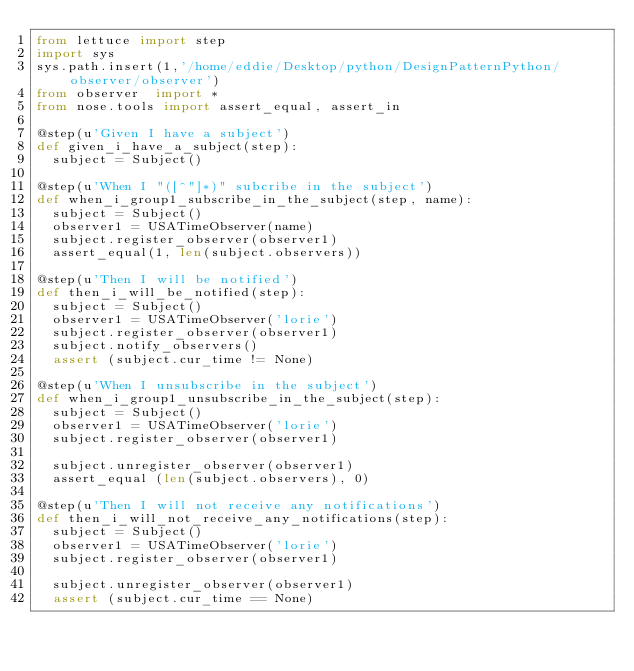<code> <loc_0><loc_0><loc_500><loc_500><_Python_>from lettuce import step
import sys
sys.path.insert(1,'/home/eddie/Desktop/python/DesignPatternPython/observer/observer')
from observer  import *
from nose.tools import assert_equal, assert_in

@step(u'Given I have a subject')
def given_i_have_a_subject(step):
  subject = Subject()

@step(u'When I "([^"]*)" subcribe in the subject')
def when_i_group1_subscribe_in_the_subject(step, name):
  subject = Subject()
  observer1 = USATimeObserver(name)
  subject.register_observer(observer1)
  assert_equal(1, len(subject.observers))

@step(u'Then I will be notified')
def then_i_will_be_notified(step):
  subject = Subject()
  observer1 = USATimeObserver('lorie')
  subject.register_observer(observer1)
  subject.notify_observers()
  assert (subject.cur_time != None)

@step(u'When I unsubscribe in the subject')
def when_i_group1_unsubscribe_in_the_subject(step):
  subject = Subject()
  observer1 = USATimeObserver('lorie')
  subject.register_observer(observer1)

  subject.unregister_observer(observer1)
  assert_equal (len(subject.observers), 0)

@step(u'Then I will not receive any notifications')
def then_i_will_not_receive_any_notifications(step):
  subject = Subject()
  observer1 = USATimeObserver('lorie')
  subject.register_observer(observer1)

  subject.unregister_observer(observer1)
  assert (subject.cur_time == None)</code> 